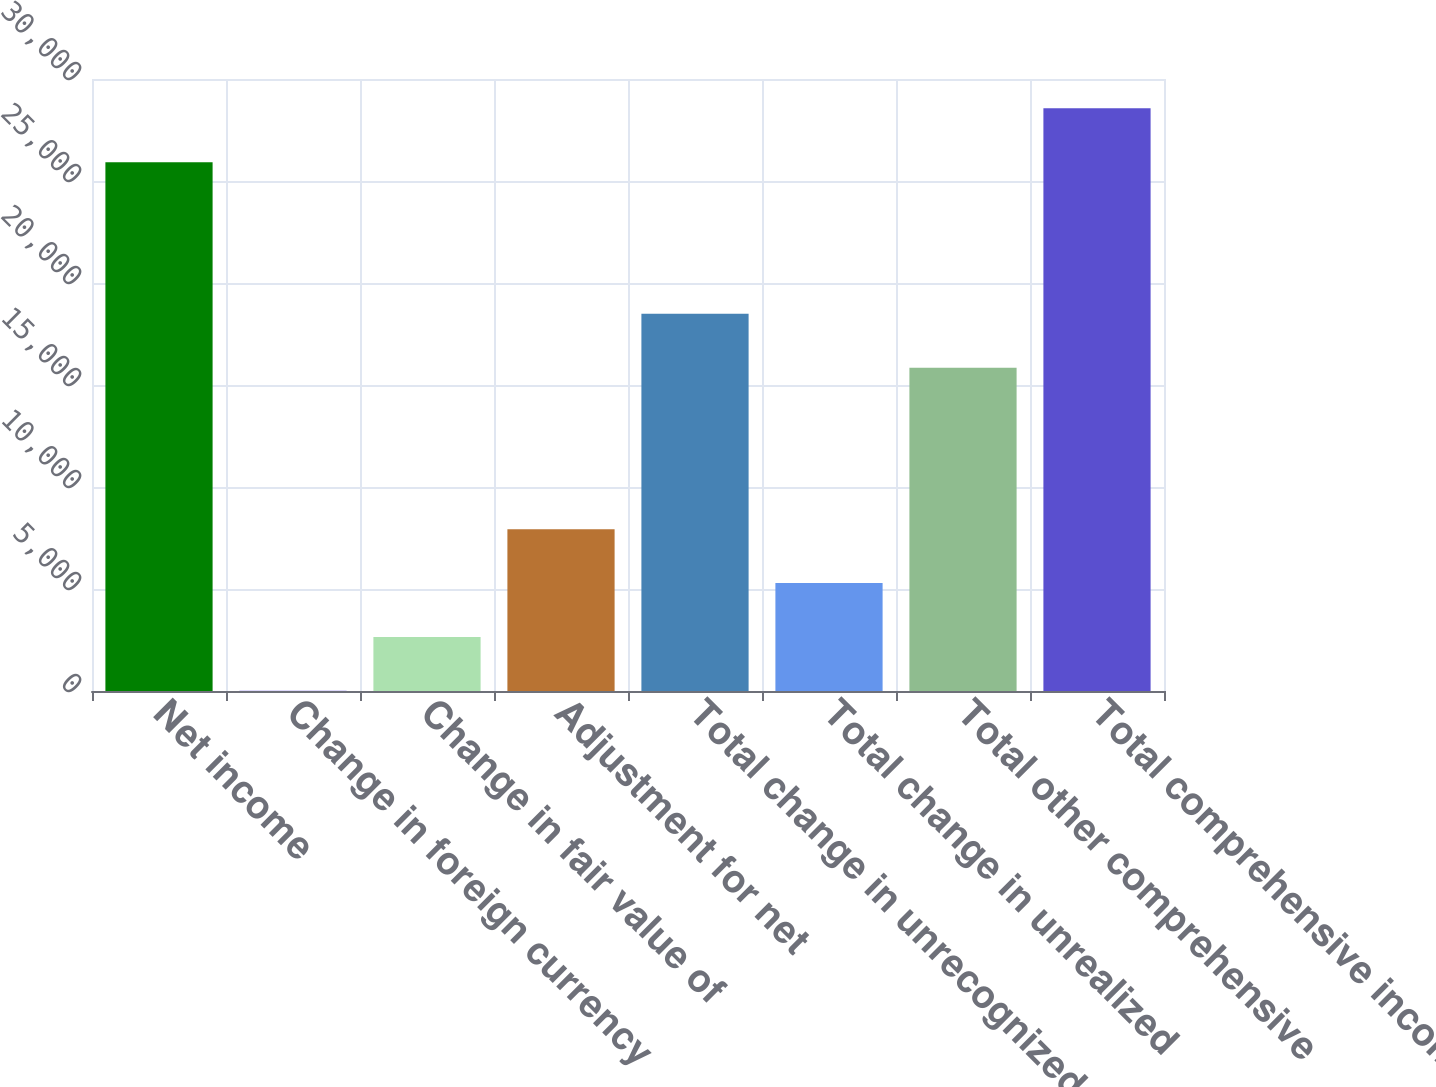<chart> <loc_0><loc_0><loc_500><loc_500><bar_chart><fcel>Net income<fcel>Change in foreign currency<fcel>Change in fair value of<fcel>Adjustment for net<fcel>Total change in unrecognized<fcel>Total change in unrealized<fcel>Total other comprehensive<fcel>Total comprehensive income<nl><fcel>25922<fcel>12<fcel>2651.9<fcel>7931.7<fcel>18491.3<fcel>5291.8<fcel>15851.4<fcel>28561.9<nl></chart> 